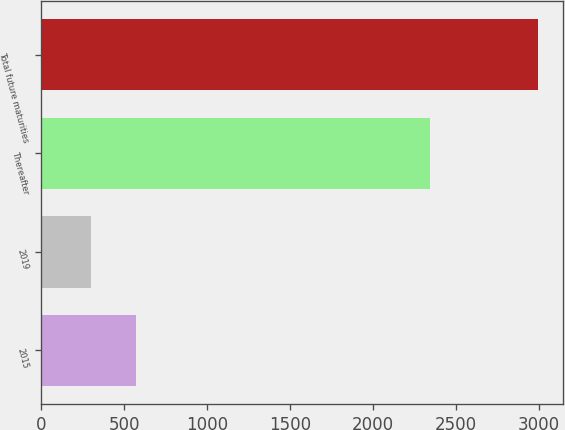<chart> <loc_0><loc_0><loc_500><loc_500><bar_chart><fcel>2015<fcel>2019<fcel>Thereafter<fcel>Total future maturities<nl><fcel>569.4<fcel>300<fcel>2344<fcel>2994<nl></chart> 